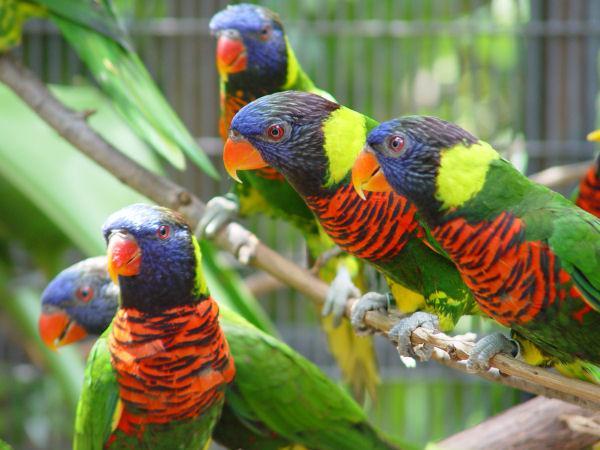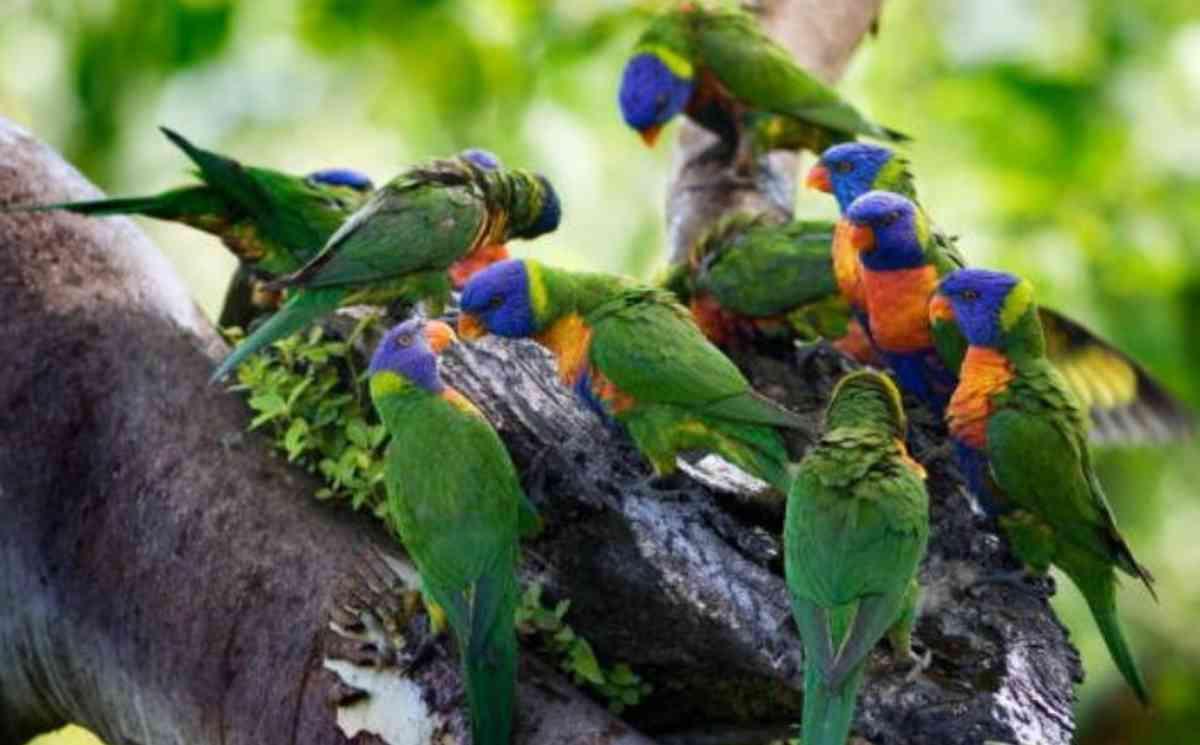The first image is the image on the left, the second image is the image on the right. Examine the images to the left and right. Is the description "An image shows a single parrot which is not in flight." accurate? Answer yes or no. No. 